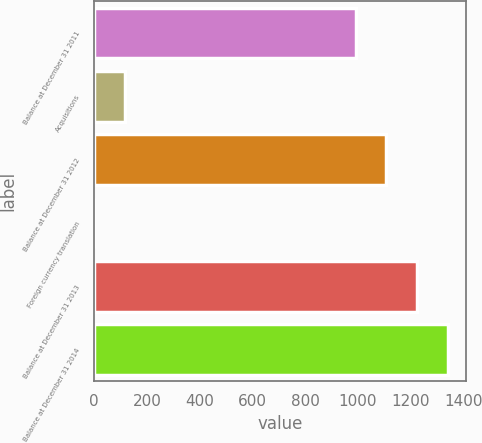<chart> <loc_0><loc_0><loc_500><loc_500><bar_chart><fcel>Balance at December 31 2011<fcel>Acquisitions<fcel>Balance at December 31 2012<fcel>Foreign currency translation<fcel>Balance at December 31 2013<fcel>Balance at December 31 2014<nl><fcel>991<fcel>117.9<fcel>1107.9<fcel>1<fcel>1224.8<fcel>1341.7<nl></chart> 